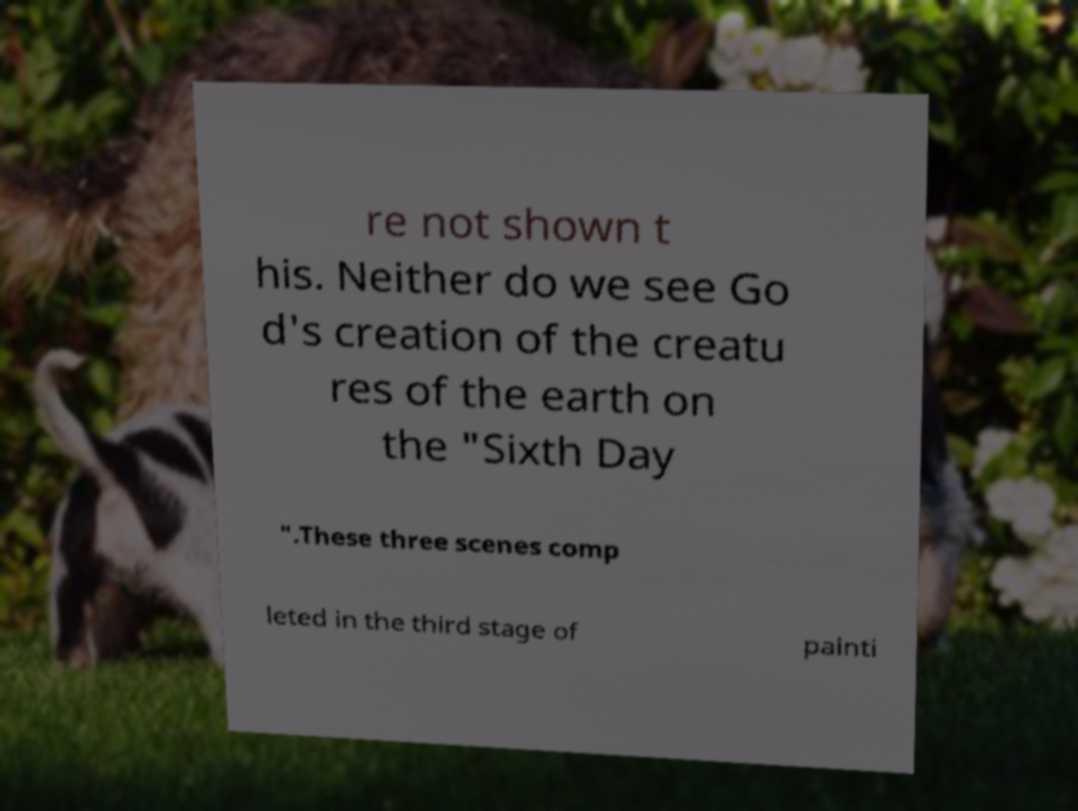I need the written content from this picture converted into text. Can you do that? re not shown t his. Neither do we see Go d's creation of the creatu res of the earth on the "Sixth Day ".These three scenes comp leted in the third stage of painti 